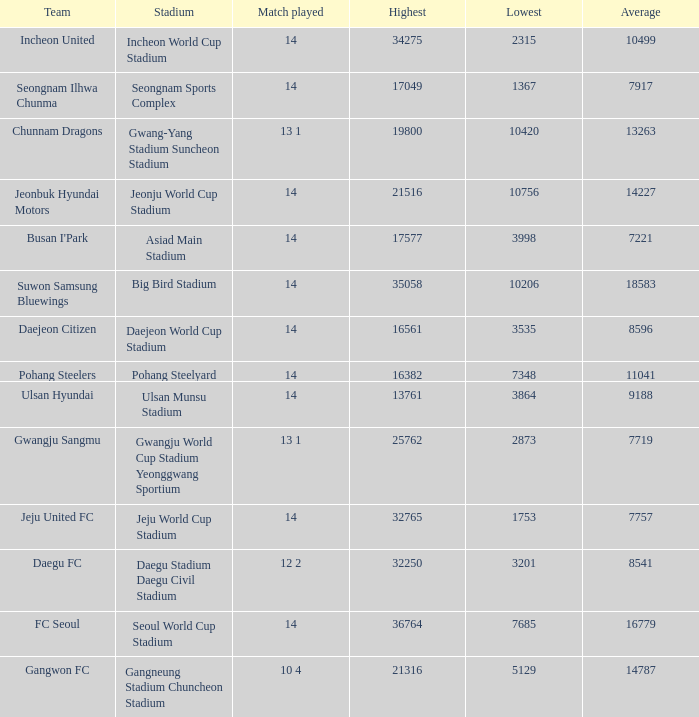Which team has 7757 as the average? Jeju United FC. 